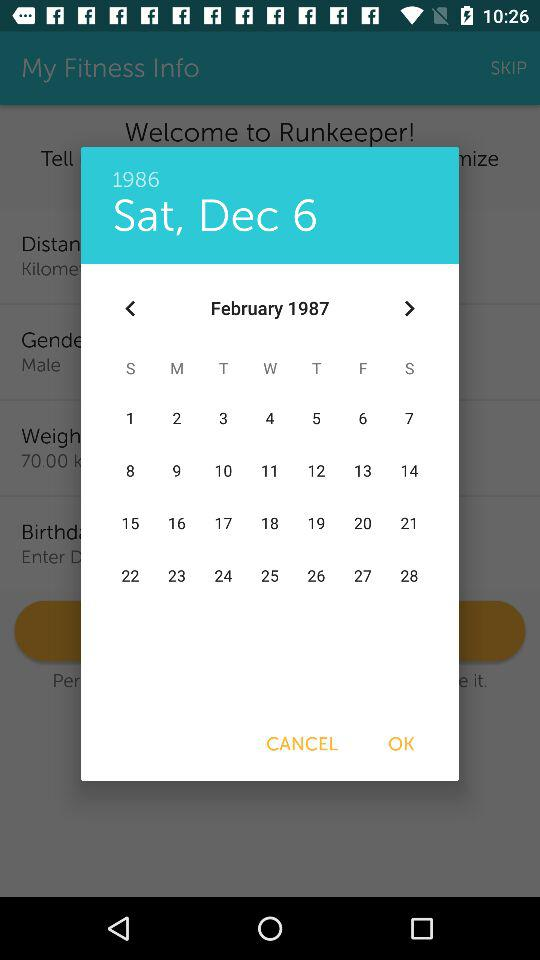Which month is shown on the calendar? The shown months are December and February. 